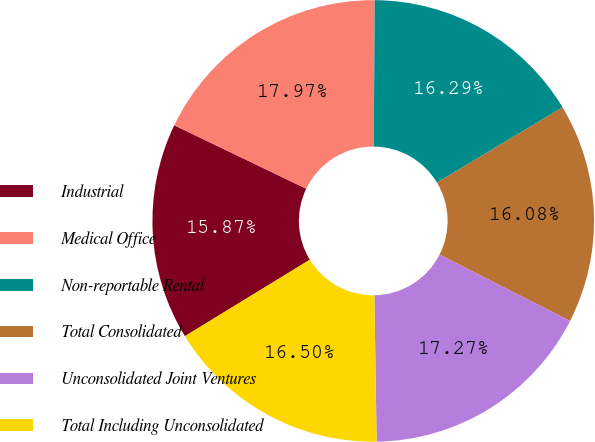<chart> <loc_0><loc_0><loc_500><loc_500><pie_chart><fcel>Industrial<fcel>Medical Office<fcel>Non-reportable Rental<fcel>Total Consolidated<fcel>Unconsolidated Joint Ventures<fcel>Total Including Unconsolidated<nl><fcel>15.87%<fcel>17.97%<fcel>16.29%<fcel>16.08%<fcel>17.27%<fcel>16.5%<nl></chart> 